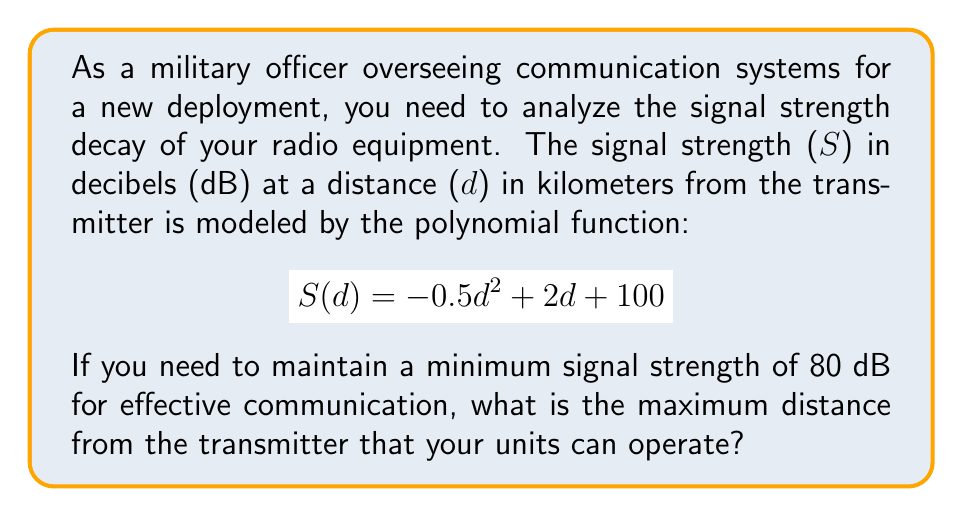Could you help me with this problem? To solve this problem, we need to find the distance at which the signal strength equals 80 dB. This involves solving the equation:

$$80 = -0.5d^2 + 2d + 100$$

Let's approach this step-by-step:

1) First, rearrange the equation to standard quadratic form:
   $$-0.5d^2 + 2d + (100 - 80) = 0$$
   $$-0.5d^2 + 2d + 20 = 0$$

2) Multiply all terms by -2 to make the coefficient of $d^2$ positive:
   $$d^2 - 4d - 40 = 0$$

3) Now we can use the quadratic formula: $d = \frac{-b \pm \sqrt{b^2 - 4ac}}{2a}$
   Where $a=1$, $b=-4$, and $c=-40$

4) Substituting these values:
   $$d = \frac{4 \pm \sqrt{(-4)^2 - 4(1)(-40)}}{2(1)}$$
   $$d = \frac{4 \pm \sqrt{16 + 160}}{2}$$
   $$d = \frac{4 \pm \sqrt{176}}{2}$$
   $$d = \frac{4 \pm 13.27}{2}$$

5) This gives us two solutions:
   $$d_1 = \frac{4 + 13.27}{2} \approx 8.64$$
   $$d_2 = \frac{4 - 13.27}{2} \approx -4.64$$

6) Since distance cannot be negative, we discard the negative solution.

Therefore, the maximum distance at which the signal strength is 80 dB is approximately 8.64 km.
Answer: 8.64 km 